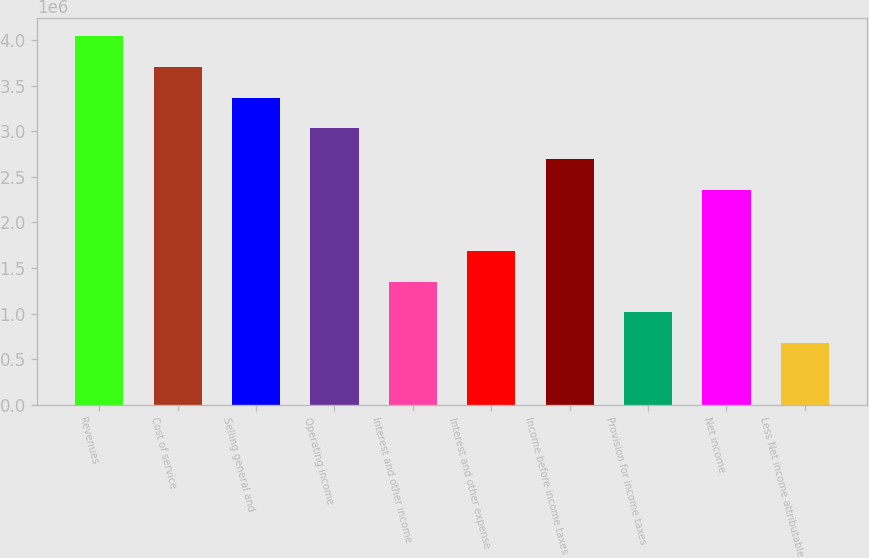Convert chart to OTSL. <chart><loc_0><loc_0><loc_500><loc_500><bar_chart><fcel>Revenues<fcel>Cost of service<fcel>Selling general and<fcel>Operating income<fcel>Interest and other income<fcel>Interest and other expense<fcel>Income before income taxes<fcel>Provision for income taxes<fcel>Net income<fcel>Less Net income attributable<nl><fcel>4.04517e+06<fcel>3.70807e+06<fcel>3.37098e+06<fcel>3.03388e+06<fcel>1.34839e+06<fcel>1.68549e+06<fcel>2.69678e+06<fcel>1.01129e+06<fcel>2.35968e+06<fcel>674196<nl></chart> 